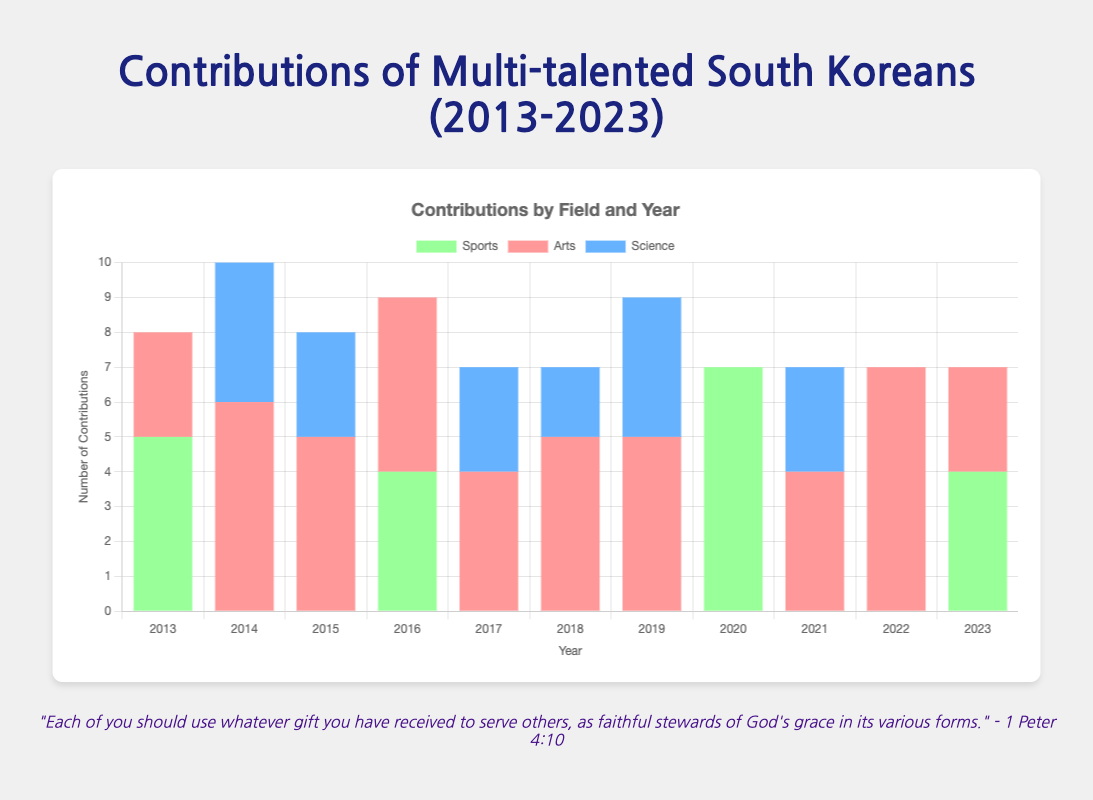What's the total number of contributions made in 2015 across all fields? To find the total number of contributions in 2015, sum the contributions from each individual in that year: 3 (Song Hye-kyo) + 2 (Kim Tae-hee) + 3 (Hwang Kyo-seok) = 8
Answer: 8 Which field had the highest total contributions in 2019? To determine which field had the highest total contributions in 2019, compare the contributions in each field: Arts (BTS, 5) and Science (Han Tae-sung, 4). Since 5 > 4, Arts had the highest contributions.
Answer: Arts What is the total number of contributions in the Science field over the decade? Sum the contributions in the Science field from every year: 4 (2014) + 3 (2015) + 3 (2017) + 2 (2018) + 4 (2019) + 3 (2021) = 19
Answer: 19 In which year did South Koreans from the Arts field contribute the most? Compare the total contributions for the Arts field across all years. The year with the highest sum in the Arts field is 2014 with 6 contributions from Bong Joon-ho.
Answer: 2014 How do the contributions in Sports in 2020 compare to 2023? Compare the total contributions in the Sports field for each year: 2020 (3 from Lee Si-young + 4 from Ryu Hyun-jin = 7) and 2023 (4 from Cha Min-kyu). Since 7 > 4, Sports contributions were higher in 2020.
Answer: 2020 Which individual had the highest single year contributions and what were they? Identify the individual with the highest contributions in a single year by checking each entry: Bong Joon-ho in 2014 with 6 contributions in Film Directing.
Answer: Bong Joon-ho with 6 contributions Are there more contributions in the Arts field than in the Sports field for the decade? Sum the contributions in Arts and Sports fields separately: 
Arts: 3 (2013) + 6 (2014) + 3+2 (2015) + 5 (2016) + 4 (2017) + 5 (2018) + 5 (2019) + 4 (2021) + 4+3 (2022) + 3 (2023) = 47 
Sports: 5 (2013) + 4 (2016) + 3+4 (2020) + 4 (2023) = 20 
Since 47 > 20, Arts contributions are more.
Answer: Yes What is the difference in total contributions between Science and Arts in 2021? Calculate total contributions in each field for 2021: 
Arts (Youn Yuh-jung, 4) and Science (Jisu Kim, 3). 
Difference = 4 - 3 = 1
Answer: 1 